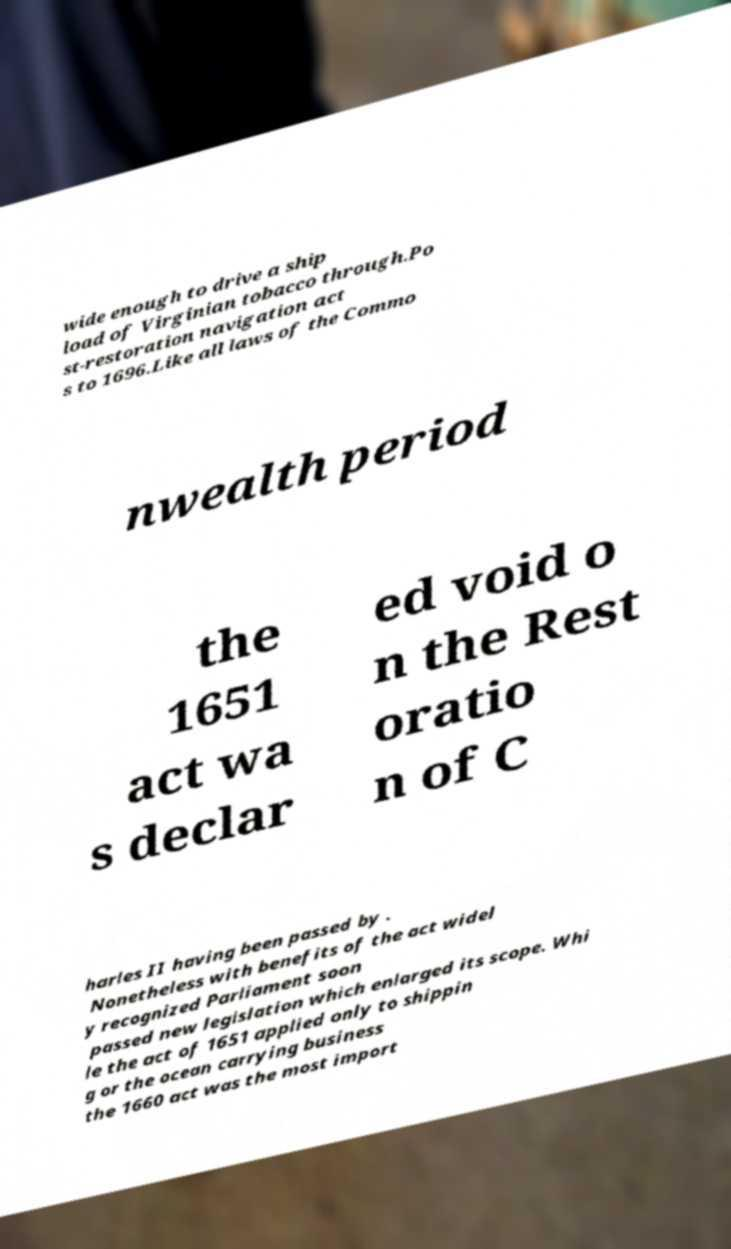Please read and relay the text visible in this image. What does it say? wide enough to drive a ship load of Virginian tobacco through.Po st-restoration navigation act s to 1696.Like all laws of the Commo nwealth period the 1651 act wa s declar ed void o n the Rest oratio n of C harles II having been passed by . Nonetheless with benefits of the act widel y recognized Parliament soon passed new legislation which enlarged its scope. Whi le the act of 1651 applied only to shippin g or the ocean carrying business the 1660 act was the most import 